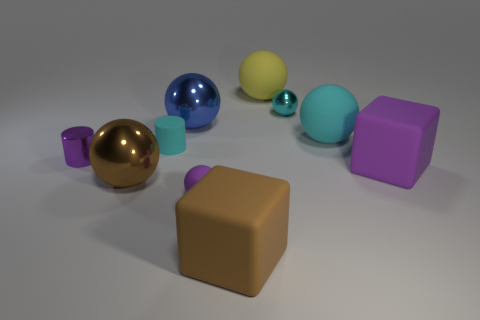How many rubber objects are either purple things or big purple cubes?
Ensure brevity in your answer.  2. Are there fewer big cyan rubber spheres than big yellow shiny cylinders?
Offer a terse response. No. Is the size of the brown metallic ball the same as the shiny ball on the right side of the big yellow rubber ball?
Ensure brevity in your answer.  No. Are there any other things that are the same shape as the blue shiny object?
Your answer should be compact. Yes. The brown sphere has what size?
Make the answer very short. Large. Are there fewer rubber cylinders that are in front of the large brown metallic ball than yellow rubber balls?
Ensure brevity in your answer.  Yes. Do the yellow object and the blue object have the same size?
Offer a very short reply. Yes. Is there any other thing that has the same size as the brown sphere?
Your answer should be compact. Yes. The tiny object that is made of the same material as the cyan cylinder is what color?
Offer a terse response. Purple. Are there fewer tiny metallic objects behind the cyan cylinder than tiny metallic balls that are on the left side of the cyan metal thing?
Keep it short and to the point. No. 